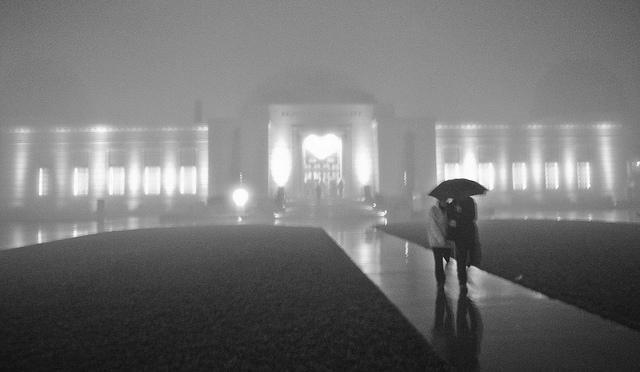What time of day is it? night 